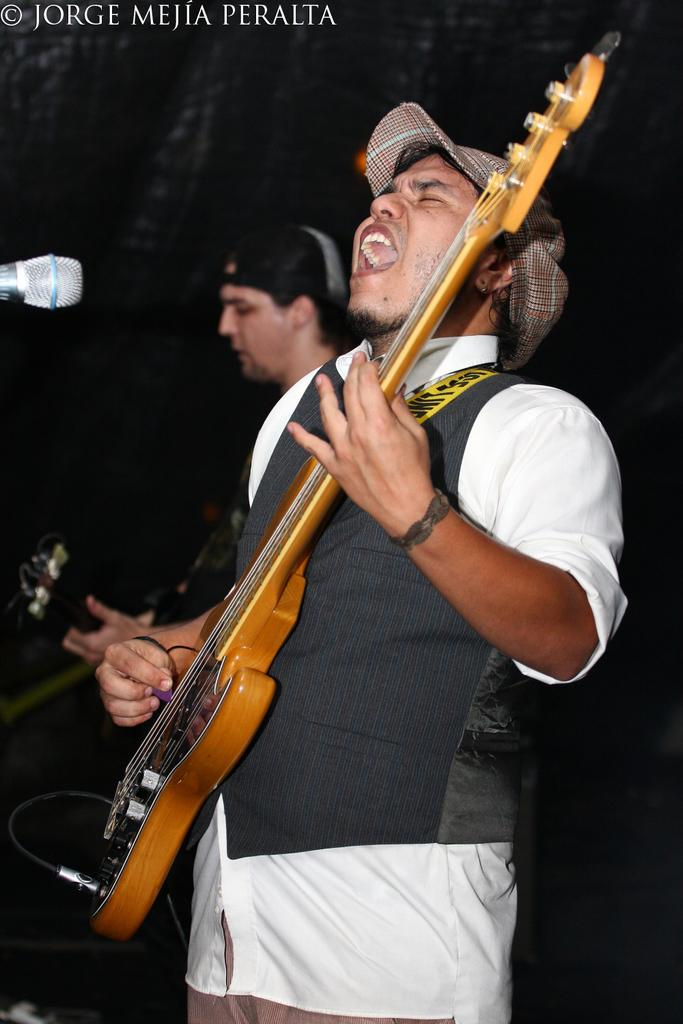What is the main subject of the image? The main subject of the image is a man standing in the middle. What is the man in the middle doing? The man in the middle is playing a guitar and singing. Are there any other people in the image? Yes, there is another man playing a guitar behind the first man. What object is present in the top left side of the image? There is a microphone in the top left side of the image. How many boats are visible in the image? There are no boats present in the image. What is the position of the zephyr in the image? There is no zephyr present in the image. 